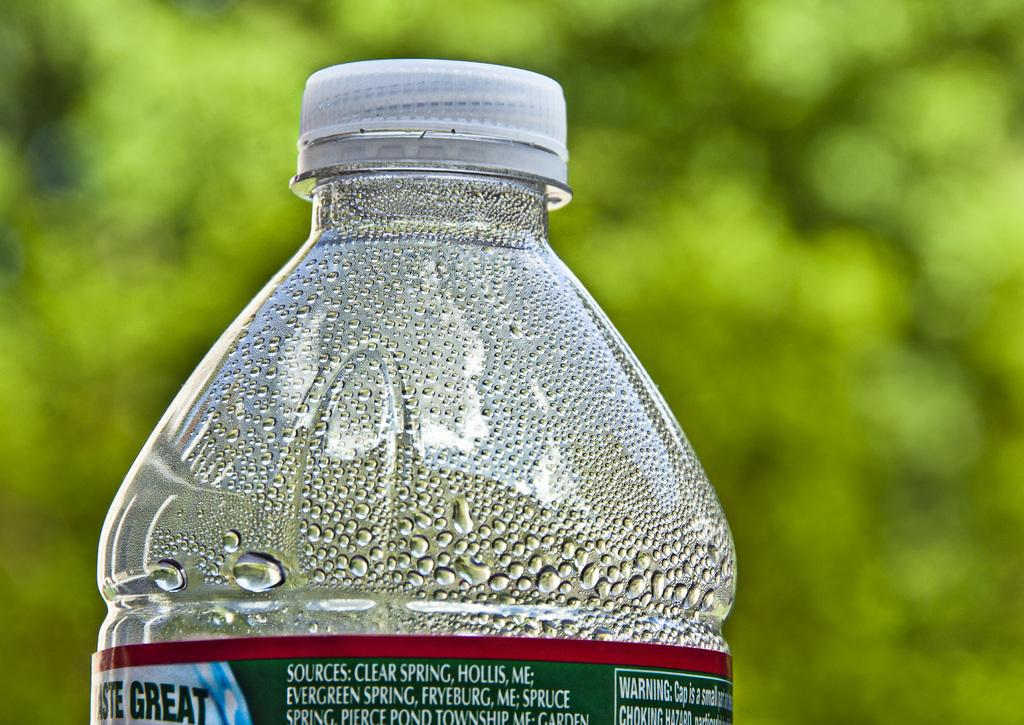Provide a one-sentence caption for the provided image. Clear spring water from the mountains of Maine. 